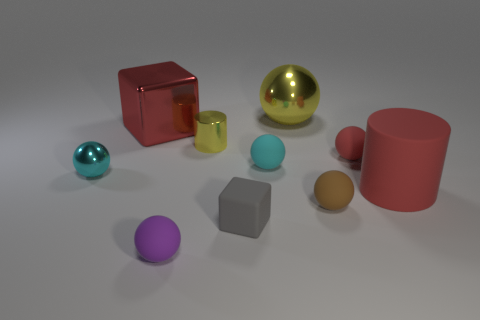What shape is the large object that is to the left of the yellow object that is in front of the large metallic block?
Provide a short and direct response. Cube. What color is the big cube?
Your answer should be compact. Red. What number of other things are there of the same size as the gray object?
Offer a very short reply. 6. There is a tiny ball that is left of the gray matte block and in front of the small metallic ball; what is it made of?
Offer a very short reply. Rubber. There is a ball on the left side of the purple rubber object; is its size the same as the big yellow thing?
Offer a terse response. No. Does the rubber cube have the same color as the large metal cube?
Your response must be concise. No. How many metal things are both on the left side of the small gray object and behind the tiny cylinder?
Ensure brevity in your answer.  1. How many cyan metal things are on the right side of the cube that is in front of the metallic thing that is in front of the small red rubber sphere?
Make the answer very short. 0. There is a cube that is the same color as the matte cylinder; what size is it?
Provide a short and direct response. Large. The big red matte object has what shape?
Ensure brevity in your answer.  Cylinder. 